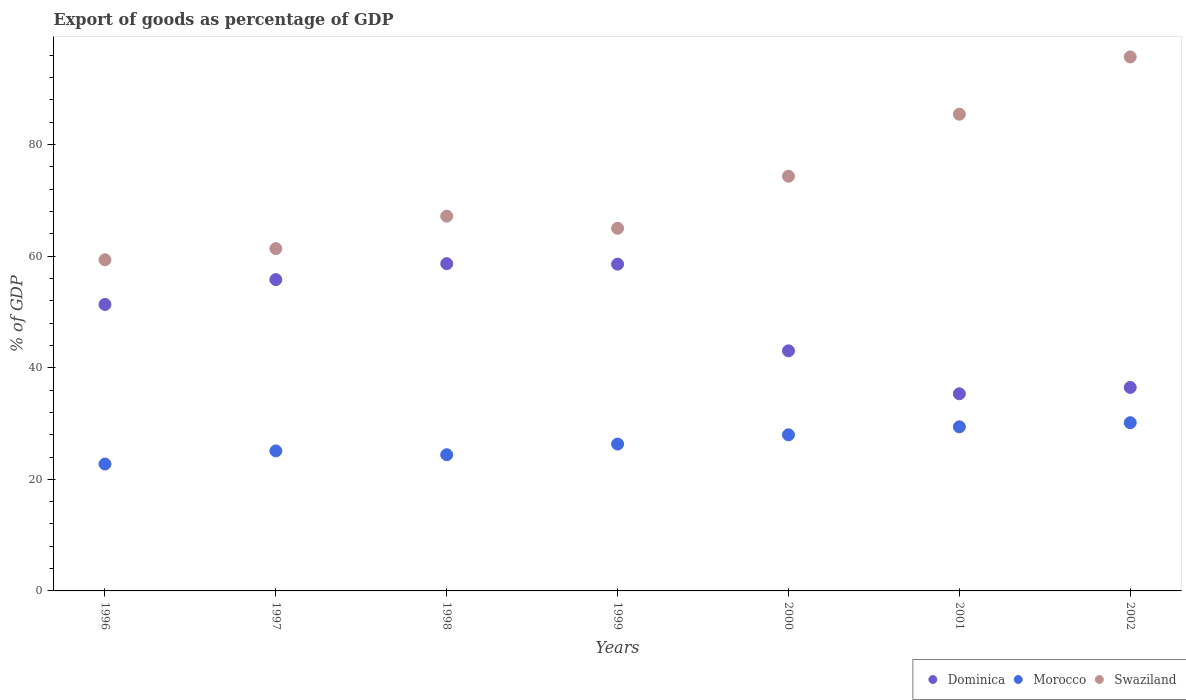Is the number of dotlines equal to the number of legend labels?
Your response must be concise. Yes. What is the export of goods as percentage of GDP in Dominica in 1998?
Your answer should be very brief. 58.66. Across all years, what is the maximum export of goods as percentage of GDP in Morocco?
Give a very brief answer. 30.15. Across all years, what is the minimum export of goods as percentage of GDP in Dominica?
Provide a short and direct response. 35.34. In which year was the export of goods as percentage of GDP in Dominica maximum?
Make the answer very short. 1998. In which year was the export of goods as percentage of GDP in Swaziland minimum?
Provide a short and direct response. 1996. What is the total export of goods as percentage of GDP in Dominica in the graph?
Provide a succinct answer. 339.21. What is the difference between the export of goods as percentage of GDP in Swaziland in 1996 and that in 2002?
Your response must be concise. -36.36. What is the difference between the export of goods as percentage of GDP in Swaziland in 2002 and the export of goods as percentage of GDP in Dominica in 2001?
Offer a very short reply. 60.37. What is the average export of goods as percentage of GDP in Dominica per year?
Make the answer very short. 48.46. In the year 1998, what is the difference between the export of goods as percentage of GDP in Morocco and export of goods as percentage of GDP in Swaziland?
Give a very brief answer. -42.76. In how many years, is the export of goods as percentage of GDP in Morocco greater than 12 %?
Give a very brief answer. 7. What is the ratio of the export of goods as percentage of GDP in Swaziland in 1999 to that in 2000?
Make the answer very short. 0.87. Is the export of goods as percentage of GDP in Dominica in 1997 less than that in 1998?
Provide a short and direct response. Yes. Is the difference between the export of goods as percentage of GDP in Morocco in 1999 and 2002 greater than the difference between the export of goods as percentage of GDP in Swaziland in 1999 and 2002?
Offer a terse response. Yes. What is the difference between the highest and the second highest export of goods as percentage of GDP in Swaziland?
Offer a terse response. 10.27. What is the difference between the highest and the lowest export of goods as percentage of GDP in Morocco?
Your response must be concise. 7.4. Does the export of goods as percentage of GDP in Swaziland monotonically increase over the years?
Offer a terse response. No. Is the export of goods as percentage of GDP in Swaziland strictly greater than the export of goods as percentage of GDP in Dominica over the years?
Make the answer very short. Yes. What is the difference between two consecutive major ticks on the Y-axis?
Your answer should be very brief. 20. Are the values on the major ticks of Y-axis written in scientific E-notation?
Ensure brevity in your answer.  No. How many legend labels are there?
Provide a short and direct response. 3. What is the title of the graph?
Your response must be concise. Export of goods as percentage of GDP. Does "Vanuatu" appear as one of the legend labels in the graph?
Offer a very short reply. No. What is the label or title of the Y-axis?
Provide a succinct answer. % of GDP. What is the % of GDP of Dominica in 1996?
Your answer should be very brief. 51.34. What is the % of GDP of Morocco in 1996?
Offer a terse response. 22.75. What is the % of GDP of Swaziland in 1996?
Make the answer very short. 59.35. What is the % of GDP of Dominica in 1997?
Provide a succinct answer. 55.8. What is the % of GDP of Morocco in 1997?
Give a very brief answer. 25.1. What is the % of GDP of Swaziland in 1997?
Make the answer very short. 61.35. What is the % of GDP in Dominica in 1998?
Ensure brevity in your answer.  58.66. What is the % of GDP in Morocco in 1998?
Provide a short and direct response. 24.41. What is the % of GDP of Swaziland in 1998?
Keep it short and to the point. 67.17. What is the % of GDP of Dominica in 1999?
Provide a succinct answer. 58.57. What is the % of GDP in Morocco in 1999?
Ensure brevity in your answer.  26.32. What is the % of GDP in Swaziland in 1999?
Ensure brevity in your answer.  65. What is the % of GDP of Dominica in 2000?
Ensure brevity in your answer.  43.03. What is the % of GDP of Morocco in 2000?
Your answer should be very brief. 27.98. What is the % of GDP of Swaziland in 2000?
Make the answer very short. 74.33. What is the % of GDP of Dominica in 2001?
Provide a succinct answer. 35.34. What is the % of GDP of Morocco in 2001?
Make the answer very short. 29.41. What is the % of GDP in Swaziland in 2001?
Ensure brevity in your answer.  85.44. What is the % of GDP of Dominica in 2002?
Your response must be concise. 36.47. What is the % of GDP in Morocco in 2002?
Give a very brief answer. 30.15. What is the % of GDP in Swaziland in 2002?
Offer a terse response. 95.71. Across all years, what is the maximum % of GDP of Dominica?
Offer a very short reply. 58.66. Across all years, what is the maximum % of GDP of Morocco?
Offer a very short reply. 30.15. Across all years, what is the maximum % of GDP of Swaziland?
Offer a very short reply. 95.71. Across all years, what is the minimum % of GDP of Dominica?
Your answer should be very brief. 35.34. Across all years, what is the minimum % of GDP in Morocco?
Provide a succinct answer. 22.75. Across all years, what is the minimum % of GDP of Swaziland?
Provide a short and direct response. 59.35. What is the total % of GDP of Dominica in the graph?
Your answer should be very brief. 339.21. What is the total % of GDP of Morocco in the graph?
Make the answer very short. 186.12. What is the total % of GDP of Swaziland in the graph?
Ensure brevity in your answer.  508.36. What is the difference between the % of GDP in Dominica in 1996 and that in 1997?
Provide a short and direct response. -4.46. What is the difference between the % of GDP of Morocco in 1996 and that in 1997?
Provide a short and direct response. -2.35. What is the difference between the % of GDP of Swaziland in 1996 and that in 1997?
Offer a very short reply. -2. What is the difference between the % of GDP of Dominica in 1996 and that in 1998?
Give a very brief answer. -7.32. What is the difference between the % of GDP in Morocco in 1996 and that in 1998?
Give a very brief answer. -1.67. What is the difference between the % of GDP in Swaziland in 1996 and that in 1998?
Provide a short and direct response. -7.82. What is the difference between the % of GDP in Dominica in 1996 and that in 1999?
Ensure brevity in your answer.  -7.23. What is the difference between the % of GDP of Morocco in 1996 and that in 1999?
Offer a very short reply. -3.58. What is the difference between the % of GDP of Swaziland in 1996 and that in 1999?
Give a very brief answer. -5.65. What is the difference between the % of GDP in Dominica in 1996 and that in 2000?
Offer a terse response. 8.31. What is the difference between the % of GDP in Morocco in 1996 and that in 2000?
Make the answer very short. -5.24. What is the difference between the % of GDP in Swaziland in 1996 and that in 2000?
Offer a very short reply. -14.97. What is the difference between the % of GDP in Dominica in 1996 and that in 2001?
Make the answer very short. 16.01. What is the difference between the % of GDP of Morocco in 1996 and that in 2001?
Your answer should be compact. -6.66. What is the difference between the % of GDP in Swaziland in 1996 and that in 2001?
Provide a succinct answer. -26.09. What is the difference between the % of GDP in Dominica in 1996 and that in 2002?
Provide a succinct answer. 14.87. What is the difference between the % of GDP in Morocco in 1996 and that in 2002?
Your answer should be compact. -7.4. What is the difference between the % of GDP in Swaziland in 1996 and that in 2002?
Ensure brevity in your answer.  -36.36. What is the difference between the % of GDP of Dominica in 1997 and that in 1998?
Your answer should be very brief. -2.86. What is the difference between the % of GDP of Morocco in 1997 and that in 1998?
Offer a terse response. 0.68. What is the difference between the % of GDP in Swaziland in 1997 and that in 1998?
Provide a succinct answer. -5.82. What is the difference between the % of GDP in Dominica in 1997 and that in 1999?
Offer a terse response. -2.77. What is the difference between the % of GDP of Morocco in 1997 and that in 1999?
Ensure brevity in your answer.  -1.23. What is the difference between the % of GDP in Swaziland in 1997 and that in 1999?
Ensure brevity in your answer.  -3.65. What is the difference between the % of GDP in Dominica in 1997 and that in 2000?
Offer a terse response. 12.77. What is the difference between the % of GDP of Morocco in 1997 and that in 2000?
Your answer should be very brief. -2.89. What is the difference between the % of GDP in Swaziland in 1997 and that in 2000?
Provide a succinct answer. -12.98. What is the difference between the % of GDP of Dominica in 1997 and that in 2001?
Provide a short and direct response. 20.46. What is the difference between the % of GDP of Morocco in 1997 and that in 2001?
Your answer should be very brief. -4.32. What is the difference between the % of GDP in Swaziland in 1997 and that in 2001?
Provide a short and direct response. -24.09. What is the difference between the % of GDP in Dominica in 1997 and that in 2002?
Offer a very short reply. 19.33. What is the difference between the % of GDP in Morocco in 1997 and that in 2002?
Provide a succinct answer. -5.06. What is the difference between the % of GDP in Swaziland in 1997 and that in 2002?
Make the answer very short. -34.36. What is the difference between the % of GDP in Dominica in 1998 and that in 1999?
Keep it short and to the point. 0.09. What is the difference between the % of GDP in Morocco in 1998 and that in 1999?
Offer a terse response. -1.91. What is the difference between the % of GDP of Swaziland in 1998 and that in 1999?
Your response must be concise. 2.17. What is the difference between the % of GDP of Dominica in 1998 and that in 2000?
Your response must be concise. 15.63. What is the difference between the % of GDP of Morocco in 1998 and that in 2000?
Ensure brevity in your answer.  -3.57. What is the difference between the % of GDP in Swaziland in 1998 and that in 2000?
Keep it short and to the point. -7.15. What is the difference between the % of GDP in Dominica in 1998 and that in 2001?
Your answer should be compact. 23.32. What is the difference between the % of GDP in Morocco in 1998 and that in 2001?
Provide a succinct answer. -5. What is the difference between the % of GDP in Swaziland in 1998 and that in 2001?
Provide a short and direct response. -18.27. What is the difference between the % of GDP of Dominica in 1998 and that in 2002?
Your answer should be very brief. 22.19. What is the difference between the % of GDP in Morocco in 1998 and that in 2002?
Make the answer very short. -5.74. What is the difference between the % of GDP of Swaziland in 1998 and that in 2002?
Your answer should be compact. -28.54. What is the difference between the % of GDP of Dominica in 1999 and that in 2000?
Give a very brief answer. 15.54. What is the difference between the % of GDP in Morocco in 1999 and that in 2000?
Offer a very short reply. -1.66. What is the difference between the % of GDP in Swaziland in 1999 and that in 2000?
Ensure brevity in your answer.  -9.33. What is the difference between the % of GDP of Dominica in 1999 and that in 2001?
Your answer should be very brief. 23.23. What is the difference between the % of GDP of Morocco in 1999 and that in 2001?
Give a very brief answer. -3.09. What is the difference between the % of GDP in Swaziland in 1999 and that in 2001?
Your answer should be very brief. -20.44. What is the difference between the % of GDP of Dominica in 1999 and that in 2002?
Your answer should be very brief. 22.1. What is the difference between the % of GDP of Morocco in 1999 and that in 2002?
Make the answer very short. -3.83. What is the difference between the % of GDP of Swaziland in 1999 and that in 2002?
Provide a short and direct response. -30.71. What is the difference between the % of GDP of Dominica in 2000 and that in 2001?
Give a very brief answer. 7.69. What is the difference between the % of GDP of Morocco in 2000 and that in 2001?
Ensure brevity in your answer.  -1.43. What is the difference between the % of GDP of Swaziland in 2000 and that in 2001?
Keep it short and to the point. -11.11. What is the difference between the % of GDP in Dominica in 2000 and that in 2002?
Ensure brevity in your answer.  6.56. What is the difference between the % of GDP of Morocco in 2000 and that in 2002?
Your response must be concise. -2.17. What is the difference between the % of GDP in Swaziland in 2000 and that in 2002?
Make the answer very short. -21.38. What is the difference between the % of GDP in Dominica in 2001 and that in 2002?
Your answer should be very brief. -1.14. What is the difference between the % of GDP in Morocco in 2001 and that in 2002?
Ensure brevity in your answer.  -0.74. What is the difference between the % of GDP of Swaziland in 2001 and that in 2002?
Offer a terse response. -10.27. What is the difference between the % of GDP in Dominica in 1996 and the % of GDP in Morocco in 1997?
Provide a short and direct response. 26.25. What is the difference between the % of GDP of Dominica in 1996 and the % of GDP of Swaziland in 1997?
Your answer should be very brief. -10.01. What is the difference between the % of GDP in Morocco in 1996 and the % of GDP in Swaziland in 1997?
Offer a very short reply. -38.6. What is the difference between the % of GDP of Dominica in 1996 and the % of GDP of Morocco in 1998?
Make the answer very short. 26.93. What is the difference between the % of GDP in Dominica in 1996 and the % of GDP in Swaziland in 1998?
Give a very brief answer. -15.83. What is the difference between the % of GDP in Morocco in 1996 and the % of GDP in Swaziland in 1998?
Make the answer very short. -44.43. What is the difference between the % of GDP of Dominica in 1996 and the % of GDP of Morocco in 1999?
Offer a very short reply. 25.02. What is the difference between the % of GDP in Dominica in 1996 and the % of GDP in Swaziland in 1999?
Keep it short and to the point. -13.66. What is the difference between the % of GDP of Morocco in 1996 and the % of GDP of Swaziland in 1999?
Offer a terse response. -42.25. What is the difference between the % of GDP of Dominica in 1996 and the % of GDP of Morocco in 2000?
Ensure brevity in your answer.  23.36. What is the difference between the % of GDP in Dominica in 1996 and the % of GDP in Swaziland in 2000?
Provide a succinct answer. -22.98. What is the difference between the % of GDP in Morocco in 1996 and the % of GDP in Swaziland in 2000?
Provide a short and direct response. -51.58. What is the difference between the % of GDP in Dominica in 1996 and the % of GDP in Morocco in 2001?
Your answer should be compact. 21.93. What is the difference between the % of GDP of Dominica in 1996 and the % of GDP of Swaziland in 2001?
Your answer should be very brief. -34.1. What is the difference between the % of GDP in Morocco in 1996 and the % of GDP in Swaziland in 2001?
Your response must be concise. -62.69. What is the difference between the % of GDP in Dominica in 1996 and the % of GDP in Morocco in 2002?
Give a very brief answer. 21.19. What is the difference between the % of GDP of Dominica in 1996 and the % of GDP of Swaziland in 2002?
Provide a succinct answer. -44.37. What is the difference between the % of GDP in Morocco in 1996 and the % of GDP in Swaziland in 2002?
Keep it short and to the point. -72.96. What is the difference between the % of GDP of Dominica in 1997 and the % of GDP of Morocco in 1998?
Make the answer very short. 31.39. What is the difference between the % of GDP in Dominica in 1997 and the % of GDP in Swaziland in 1998?
Keep it short and to the point. -11.37. What is the difference between the % of GDP in Morocco in 1997 and the % of GDP in Swaziland in 1998?
Give a very brief answer. -42.08. What is the difference between the % of GDP of Dominica in 1997 and the % of GDP of Morocco in 1999?
Your answer should be compact. 29.48. What is the difference between the % of GDP of Dominica in 1997 and the % of GDP of Swaziland in 1999?
Ensure brevity in your answer.  -9.2. What is the difference between the % of GDP in Morocco in 1997 and the % of GDP in Swaziland in 1999?
Your answer should be very brief. -39.9. What is the difference between the % of GDP in Dominica in 1997 and the % of GDP in Morocco in 2000?
Provide a short and direct response. 27.82. What is the difference between the % of GDP of Dominica in 1997 and the % of GDP of Swaziland in 2000?
Your answer should be compact. -18.53. What is the difference between the % of GDP of Morocco in 1997 and the % of GDP of Swaziland in 2000?
Offer a terse response. -49.23. What is the difference between the % of GDP in Dominica in 1997 and the % of GDP in Morocco in 2001?
Your answer should be very brief. 26.39. What is the difference between the % of GDP of Dominica in 1997 and the % of GDP of Swaziland in 2001?
Make the answer very short. -29.64. What is the difference between the % of GDP of Morocco in 1997 and the % of GDP of Swaziland in 2001?
Make the answer very short. -60.35. What is the difference between the % of GDP in Dominica in 1997 and the % of GDP in Morocco in 2002?
Give a very brief answer. 25.65. What is the difference between the % of GDP of Dominica in 1997 and the % of GDP of Swaziland in 2002?
Your answer should be compact. -39.91. What is the difference between the % of GDP in Morocco in 1997 and the % of GDP in Swaziland in 2002?
Your answer should be very brief. -70.62. What is the difference between the % of GDP in Dominica in 1998 and the % of GDP in Morocco in 1999?
Ensure brevity in your answer.  32.34. What is the difference between the % of GDP in Dominica in 1998 and the % of GDP in Swaziland in 1999?
Your answer should be compact. -6.34. What is the difference between the % of GDP of Morocco in 1998 and the % of GDP of Swaziland in 1999?
Give a very brief answer. -40.59. What is the difference between the % of GDP in Dominica in 1998 and the % of GDP in Morocco in 2000?
Keep it short and to the point. 30.68. What is the difference between the % of GDP in Dominica in 1998 and the % of GDP in Swaziland in 2000?
Provide a succinct answer. -15.67. What is the difference between the % of GDP of Morocco in 1998 and the % of GDP of Swaziland in 2000?
Make the answer very short. -49.91. What is the difference between the % of GDP of Dominica in 1998 and the % of GDP of Morocco in 2001?
Provide a succinct answer. 29.25. What is the difference between the % of GDP in Dominica in 1998 and the % of GDP in Swaziland in 2001?
Provide a succinct answer. -26.78. What is the difference between the % of GDP in Morocco in 1998 and the % of GDP in Swaziland in 2001?
Your answer should be very brief. -61.03. What is the difference between the % of GDP of Dominica in 1998 and the % of GDP of Morocco in 2002?
Make the answer very short. 28.51. What is the difference between the % of GDP of Dominica in 1998 and the % of GDP of Swaziland in 2002?
Ensure brevity in your answer.  -37.05. What is the difference between the % of GDP of Morocco in 1998 and the % of GDP of Swaziland in 2002?
Provide a succinct answer. -71.3. What is the difference between the % of GDP of Dominica in 1999 and the % of GDP of Morocco in 2000?
Keep it short and to the point. 30.59. What is the difference between the % of GDP of Dominica in 1999 and the % of GDP of Swaziland in 2000?
Your response must be concise. -15.76. What is the difference between the % of GDP of Morocco in 1999 and the % of GDP of Swaziland in 2000?
Provide a short and direct response. -48. What is the difference between the % of GDP of Dominica in 1999 and the % of GDP of Morocco in 2001?
Make the answer very short. 29.16. What is the difference between the % of GDP in Dominica in 1999 and the % of GDP in Swaziland in 2001?
Your response must be concise. -26.87. What is the difference between the % of GDP in Morocco in 1999 and the % of GDP in Swaziland in 2001?
Your response must be concise. -59.12. What is the difference between the % of GDP in Dominica in 1999 and the % of GDP in Morocco in 2002?
Give a very brief answer. 28.42. What is the difference between the % of GDP in Dominica in 1999 and the % of GDP in Swaziland in 2002?
Provide a short and direct response. -37.14. What is the difference between the % of GDP of Morocco in 1999 and the % of GDP of Swaziland in 2002?
Give a very brief answer. -69.39. What is the difference between the % of GDP of Dominica in 2000 and the % of GDP of Morocco in 2001?
Your answer should be compact. 13.62. What is the difference between the % of GDP in Dominica in 2000 and the % of GDP in Swaziland in 2001?
Provide a short and direct response. -42.41. What is the difference between the % of GDP in Morocco in 2000 and the % of GDP in Swaziland in 2001?
Provide a succinct answer. -57.46. What is the difference between the % of GDP in Dominica in 2000 and the % of GDP in Morocco in 2002?
Your answer should be compact. 12.88. What is the difference between the % of GDP of Dominica in 2000 and the % of GDP of Swaziland in 2002?
Keep it short and to the point. -52.68. What is the difference between the % of GDP of Morocco in 2000 and the % of GDP of Swaziland in 2002?
Give a very brief answer. -67.73. What is the difference between the % of GDP of Dominica in 2001 and the % of GDP of Morocco in 2002?
Your answer should be compact. 5.19. What is the difference between the % of GDP in Dominica in 2001 and the % of GDP in Swaziland in 2002?
Give a very brief answer. -60.37. What is the difference between the % of GDP of Morocco in 2001 and the % of GDP of Swaziland in 2002?
Offer a very short reply. -66.3. What is the average % of GDP of Dominica per year?
Offer a very short reply. 48.46. What is the average % of GDP of Morocco per year?
Your answer should be compact. 26.59. What is the average % of GDP of Swaziland per year?
Your answer should be very brief. 72.62. In the year 1996, what is the difference between the % of GDP of Dominica and % of GDP of Morocco?
Provide a succinct answer. 28.6. In the year 1996, what is the difference between the % of GDP in Dominica and % of GDP in Swaziland?
Your answer should be compact. -8.01. In the year 1996, what is the difference between the % of GDP in Morocco and % of GDP in Swaziland?
Provide a succinct answer. -36.61. In the year 1997, what is the difference between the % of GDP in Dominica and % of GDP in Morocco?
Offer a terse response. 30.71. In the year 1997, what is the difference between the % of GDP of Dominica and % of GDP of Swaziland?
Your answer should be very brief. -5.55. In the year 1997, what is the difference between the % of GDP in Morocco and % of GDP in Swaziland?
Offer a terse response. -36.26. In the year 1998, what is the difference between the % of GDP in Dominica and % of GDP in Morocco?
Provide a short and direct response. 34.25. In the year 1998, what is the difference between the % of GDP in Dominica and % of GDP in Swaziland?
Your answer should be compact. -8.51. In the year 1998, what is the difference between the % of GDP of Morocco and % of GDP of Swaziland?
Provide a succinct answer. -42.76. In the year 1999, what is the difference between the % of GDP of Dominica and % of GDP of Morocco?
Your answer should be compact. 32.25. In the year 1999, what is the difference between the % of GDP of Dominica and % of GDP of Swaziland?
Make the answer very short. -6.43. In the year 1999, what is the difference between the % of GDP of Morocco and % of GDP of Swaziland?
Make the answer very short. -38.68. In the year 2000, what is the difference between the % of GDP of Dominica and % of GDP of Morocco?
Provide a succinct answer. 15.05. In the year 2000, what is the difference between the % of GDP of Dominica and % of GDP of Swaziland?
Your answer should be very brief. -31.3. In the year 2000, what is the difference between the % of GDP of Morocco and % of GDP of Swaziland?
Provide a short and direct response. -46.34. In the year 2001, what is the difference between the % of GDP in Dominica and % of GDP in Morocco?
Your answer should be very brief. 5.93. In the year 2001, what is the difference between the % of GDP of Dominica and % of GDP of Swaziland?
Your answer should be very brief. -50.1. In the year 2001, what is the difference between the % of GDP in Morocco and % of GDP in Swaziland?
Give a very brief answer. -56.03. In the year 2002, what is the difference between the % of GDP of Dominica and % of GDP of Morocco?
Keep it short and to the point. 6.32. In the year 2002, what is the difference between the % of GDP in Dominica and % of GDP in Swaziland?
Provide a succinct answer. -59.24. In the year 2002, what is the difference between the % of GDP in Morocco and % of GDP in Swaziland?
Offer a terse response. -65.56. What is the ratio of the % of GDP in Dominica in 1996 to that in 1997?
Offer a terse response. 0.92. What is the ratio of the % of GDP in Morocco in 1996 to that in 1997?
Make the answer very short. 0.91. What is the ratio of the % of GDP of Swaziland in 1996 to that in 1997?
Give a very brief answer. 0.97. What is the ratio of the % of GDP in Dominica in 1996 to that in 1998?
Provide a short and direct response. 0.88. What is the ratio of the % of GDP in Morocco in 1996 to that in 1998?
Give a very brief answer. 0.93. What is the ratio of the % of GDP of Swaziland in 1996 to that in 1998?
Ensure brevity in your answer.  0.88. What is the ratio of the % of GDP in Dominica in 1996 to that in 1999?
Make the answer very short. 0.88. What is the ratio of the % of GDP in Morocco in 1996 to that in 1999?
Give a very brief answer. 0.86. What is the ratio of the % of GDP in Swaziland in 1996 to that in 1999?
Keep it short and to the point. 0.91. What is the ratio of the % of GDP of Dominica in 1996 to that in 2000?
Your answer should be compact. 1.19. What is the ratio of the % of GDP in Morocco in 1996 to that in 2000?
Keep it short and to the point. 0.81. What is the ratio of the % of GDP of Swaziland in 1996 to that in 2000?
Provide a succinct answer. 0.8. What is the ratio of the % of GDP of Dominica in 1996 to that in 2001?
Your response must be concise. 1.45. What is the ratio of the % of GDP of Morocco in 1996 to that in 2001?
Your answer should be compact. 0.77. What is the ratio of the % of GDP of Swaziland in 1996 to that in 2001?
Offer a very short reply. 0.69. What is the ratio of the % of GDP in Dominica in 1996 to that in 2002?
Ensure brevity in your answer.  1.41. What is the ratio of the % of GDP of Morocco in 1996 to that in 2002?
Offer a very short reply. 0.75. What is the ratio of the % of GDP in Swaziland in 1996 to that in 2002?
Ensure brevity in your answer.  0.62. What is the ratio of the % of GDP of Dominica in 1997 to that in 1998?
Your answer should be very brief. 0.95. What is the ratio of the % of GDP in Morocco in 1997 to that in 1998?
Offer a terse response. 1.03. What is the ratio of the % of GDP in Swaziland in 1997 to that in 1998?
Your answer should be very brief. 0.91. What is the ratio of the % of GDP of Dominica in 1997 to that in 1999?
Offer a very short reply. 0.95. What is the ratio of the % of GDP in Morocco in 1997 to that in 1999?
Offer a terse response. 0.95. What is the ratio of the % of GDP of Swaziland in 1997 to that in 1999?
Keep it short and to the point. 0.94. What is the ratio of the % of GDP in Dominica in 1997 to that in 2000?
Provide a short and direct response. 1.3. What is the ratio of the % of GDP of Morocco in 1997 to that in 2000?
Give a very brief answer. 0.9. What is the ratio of the % of GDP in Swaziland in 1997 to that in 2000?
Give a very brief answer. 0.83. What is the ratio of the % of GDP in Dominica in 1997 to that in 2001?
Your answer should be very brief. 1.58. What is the ratio of the % of GDP in Morocco in 1997 to that in 2001?
Give a very brief answer. 0.85. What is the ratio of the % of GDP in Swaziland in 1997 to that in 2001?
Your answer should be compact. 0.72. What is the ratio of the % of GDP in Dominica in 1997 to that in 2002?
Give a very brief answer. 1.53. What is the ratio of the % of GDP in Morocco in 1997 to that in 2002?
Make the answer very short. 0.83. What is the ratio of the % of GDP of Swaziland in 1997 to that in 2002?
Your response must be concise. 0.64. What is the ratio of the % of GDP in Morocco in 1998 to that in 1999?
Your response must be concise. 0.93. What is the ratio of the % of GDP of Swaziland in 1998 to that in 1999?
Keep it short and to the point. 1.03. What is the ratio of the % of GDP in Dominica in 1998 to that in 2000?
Make the answer very short. 1.36. What is the ratio of the % of GDP in Morocco in 1998 to that in 2000?
Provide a short and direct response. 0.87. What is the ratio of the % of GDP in Swaziland in 1998 to that in 2000?
Keep it short and to the point. 0.9. What is the ratio of the % of GDP in Dominica in 1998 to that in 2001?
Your answer should be very brief. 1.66. What is the ratio of the % of GDP of Morocco in 1998 to that in 2001?
Your answer should be very brief. 0.83. What is the ratio of the % of GDP in Swaziland in 1998 to that in 2001?
Offer a very short reply. 0.79. What is the ratio of the % of GDP of Dominica in 1998 to that in 2002?
Offer a terse response. 1.61. What is the ratio of the % of GDP in Morocco in 1998 to that in 2002?
Your answer should be compact. 0.81. What is the ratio of the % of GDP of Swaziland in 1998 to that in 2002?
Keep it short and to the point. 0.7. What is the ratio of the % of GDP in Dominica in 1999 to that in 2000?
Offer a terse response. 1.36. What is the ratio of the % of GDP of Morocco in 1999 to that in 2000?
Offer a terse response. 0.94. What is the ratio of the % of GDP in Swaziland in 1999 to that in 2000?
Ensure brevity in your answer.  0.87. What is the ratio of the % of GDP in Dominica in 1999 to that in 2001?
Your response must be concise. 1.66. What is the ratio of the % of GDP in Morocco in 1999 to that in 2001?
Ensure brevity in your answer.  0.9. What is the ratio of the % of GDP of Swaziland in 1999 to that in 2001?
Your answer should be very brief. 0.76. What is the ratio of the % of GDP of Dominica in 1999 to that in 2002?
Your response must be concise. 1.61. What is the ratio of the % of GDP of Morocco in 1999 to that in 2002?
Your answer should be very brief. 0.87. What is the ratio of the % of GDP of Swaziland in 1999 to that in 2002?
Your answer should be very brief. 0.68. What is the ratio of the % of GDP in Dominica in 2000 to that in 2001?
Make the answer very short. 1.22. What is the ratio of the % of GDP of Morocco in 2000 to that in 2001?
Your answer should be very brief. 0.95. What is the ratio of the % of GDP in Swaziland in 2000 to that in 2001?
Keep it short and to the point. 0.87. What is the ratio of the % of GDP in Dominica in 2000 to that in 2002?
Make the answer very short. 1.18. What is the ratio of the % of GDP of Morocco in 2000 to that in 2002?
Keep it short and to the point. 0.93. What is the ratio of the % of GDP of Swaziland in 2000 to that in 2002?
Keep it short and to the point. 0.78. What is the ratio of the % of GDP of Dominica in 2001 to that in 2002?
Provide a short and direct response. 0.97. What is the ratio of the % of GDP of Morocco in 2001 to that in 2002?
Your answer should be very brief. 0.98. What is the ratio of the % of GDP of Swaziland in 2001 to that in 2002?
Your answer should be compact. 0.89. What is the difference between the highest and the second highest % of GDP of Dominica?
Keep it short and to the point. 0.09. What is the difference between the highest and the second highest % of GDP of Morocco?
Offer a terse response. 0.74. What is the difference between the highest and the second highest % of GDP in Swaziland?
Provide a succinct answer. 10.27. What is the difference between the highest and the lowest % of GDP in Dominica?
Provide a succinct answer. 23.32. What is the difference between the highest and the lowest % of GDP in Morocco?
Your answer should be compact. 7.4. What is the difference between the highest and the lowest % of GDP in Swaziland?
Your answer should be compact. 36.36. 